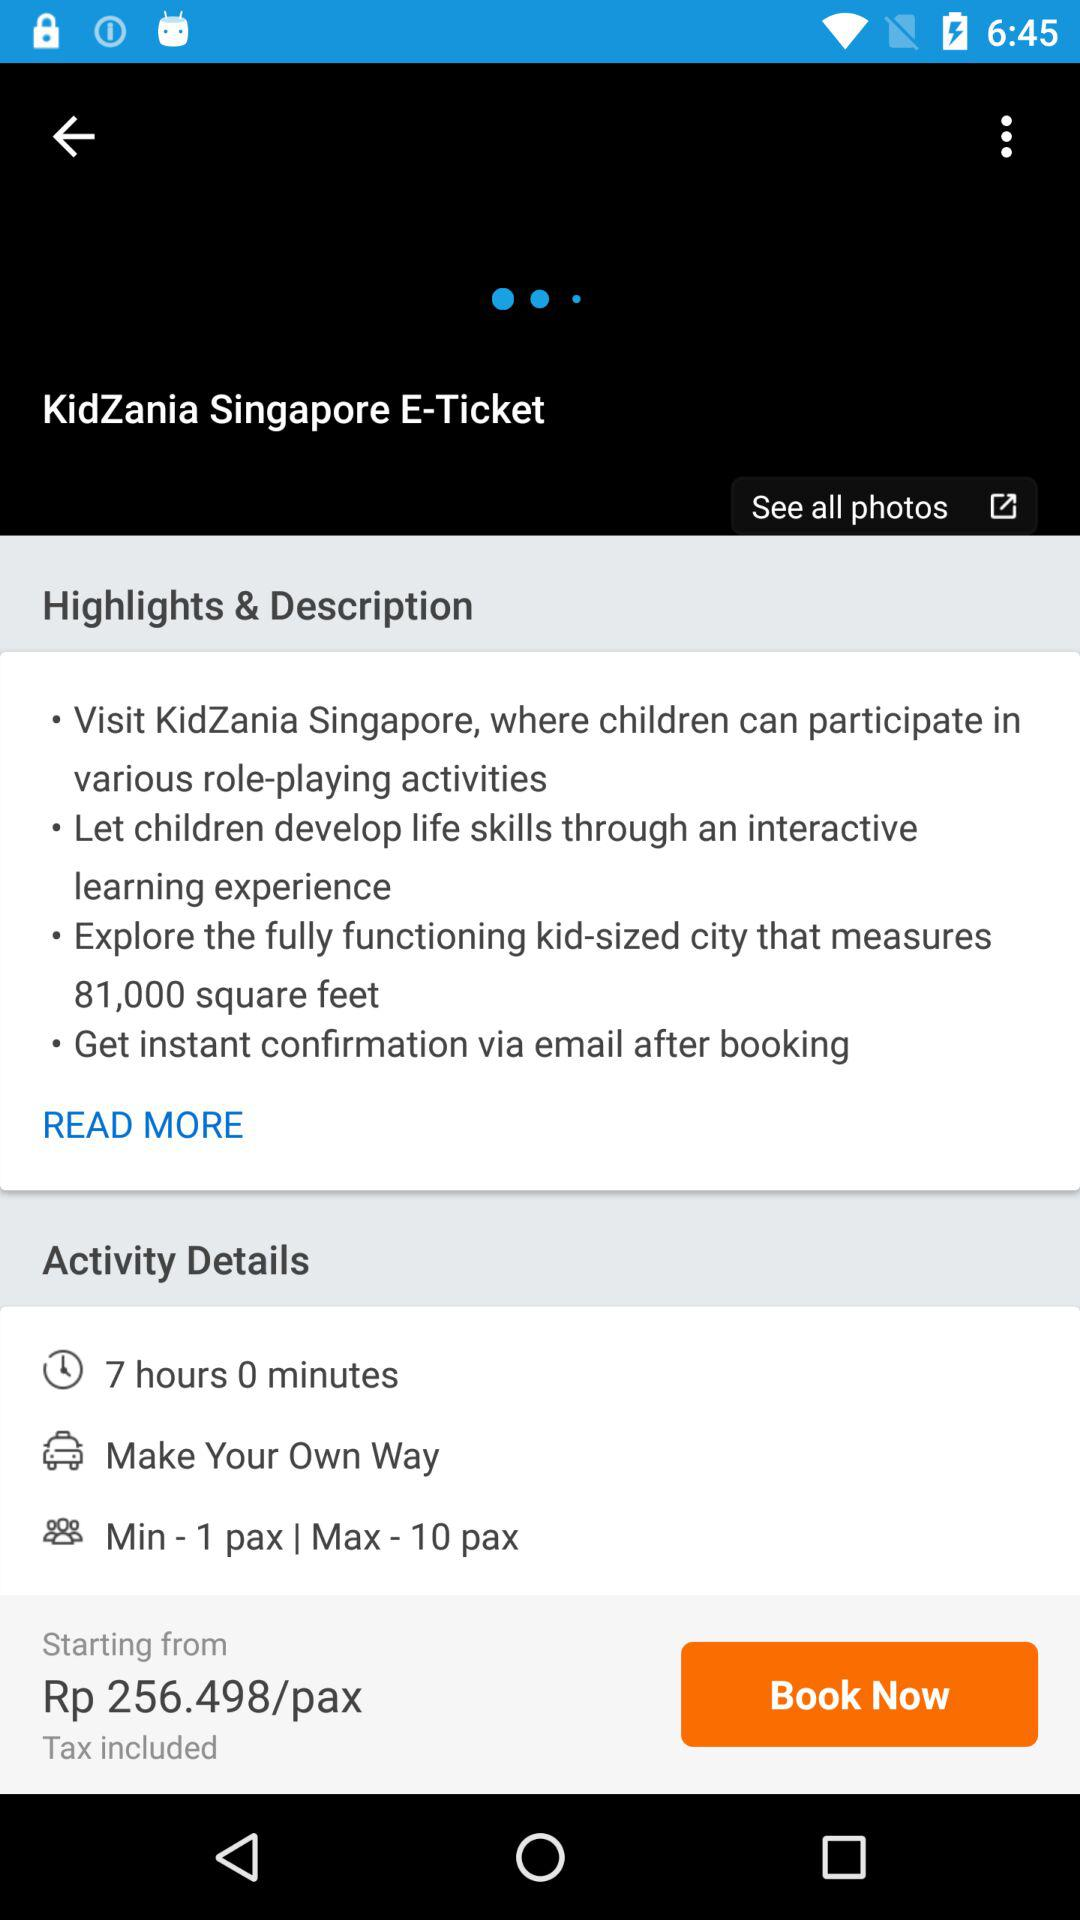What is the address of KidZania Singapore?
When the provided information is insufficient, respond with <no answer>. <no answer> 